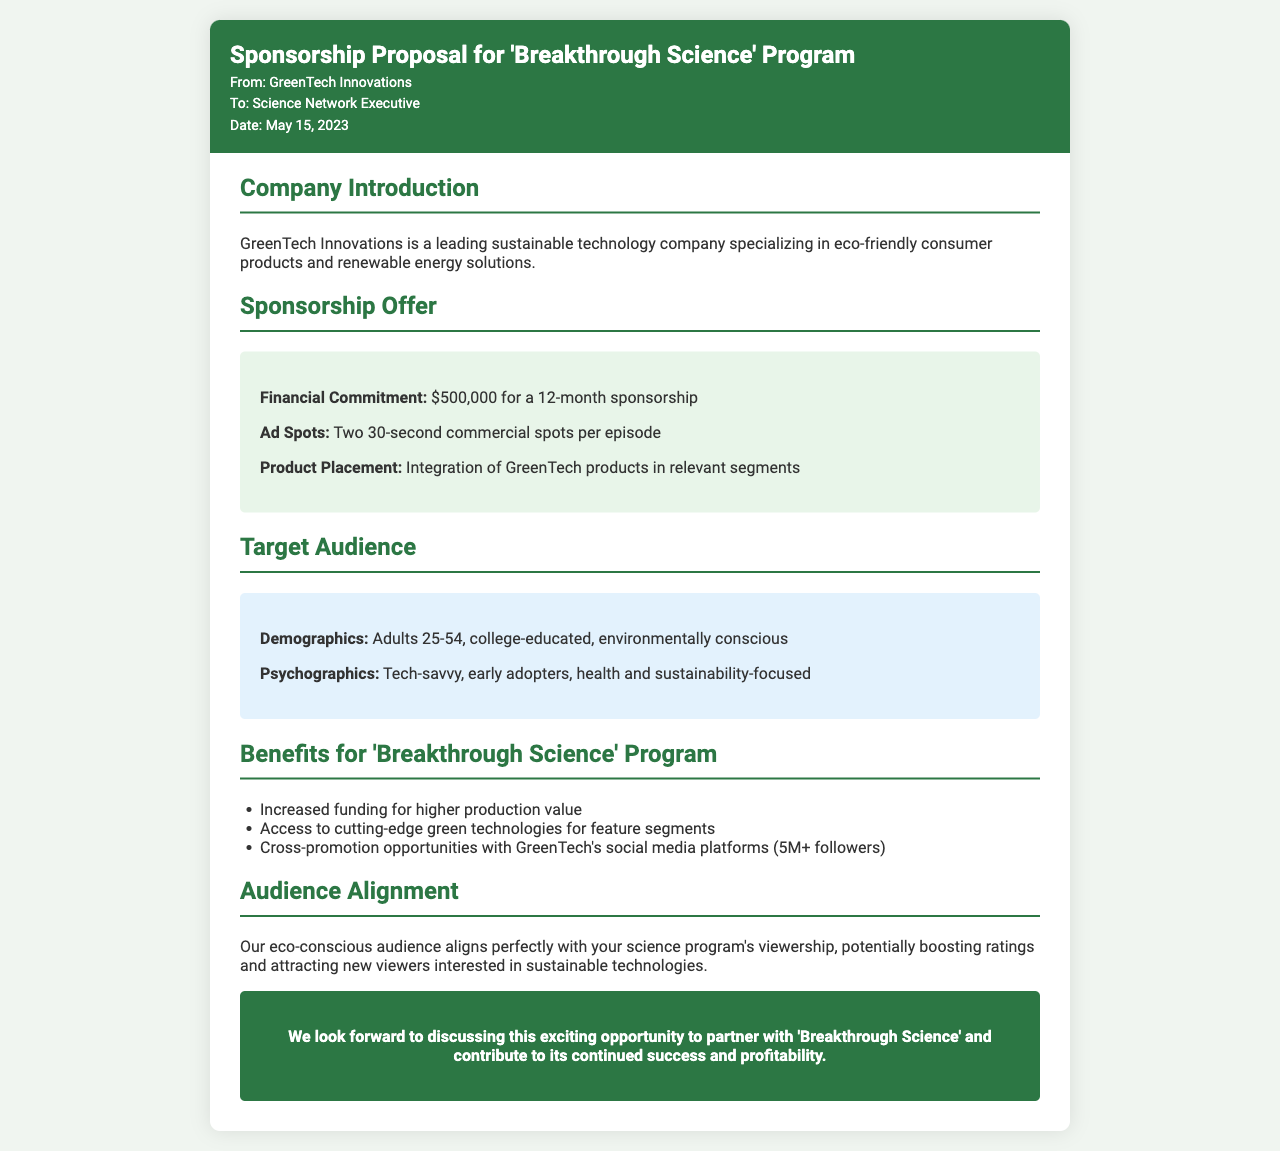what is the financial commitment for the sponsorship? The document states that the financial commitment for the sponsorship is $500,000 for a 12-month sponsorship.
Answer: $500,000 how many commercial spots are included per episode? According to the proposal, there are two 30-second commercial spots included per episode.
Answer: Two what is the target demographic age range? The target demographic age range specified in the document is adults 25-54.
Answer: 25-54 which company is presenting the sponsorship proposal? The name of the company presenting the sponsorship proposal is GreenTech Innovations.
Answer: GreenTech Innovations how does the audience alignment benefit the program? The alignment with the eco-conscious audience can potentially boost ratings and attract new viewers interested in sustainable technologies.
Answer: Boost ratings what type of products will be integrated in the program? The proposal mentions the integration of GreenTech products in relevant segments.
Answer: GreenTech products what benefits does the sponsorship offer to the program? Increased funding for higher production value is one of the benefits outlined in the proposal.
Answer: Increased funding how many social media followers does GreenTech have? The document indicates that GreenTech has over 5 million followers on their social media platforms.
Answer: 5M+ what type of document is this? This document is a sponsorship proposal fax from a potential advertiser.
Answer: Sponsorship proposal fax 